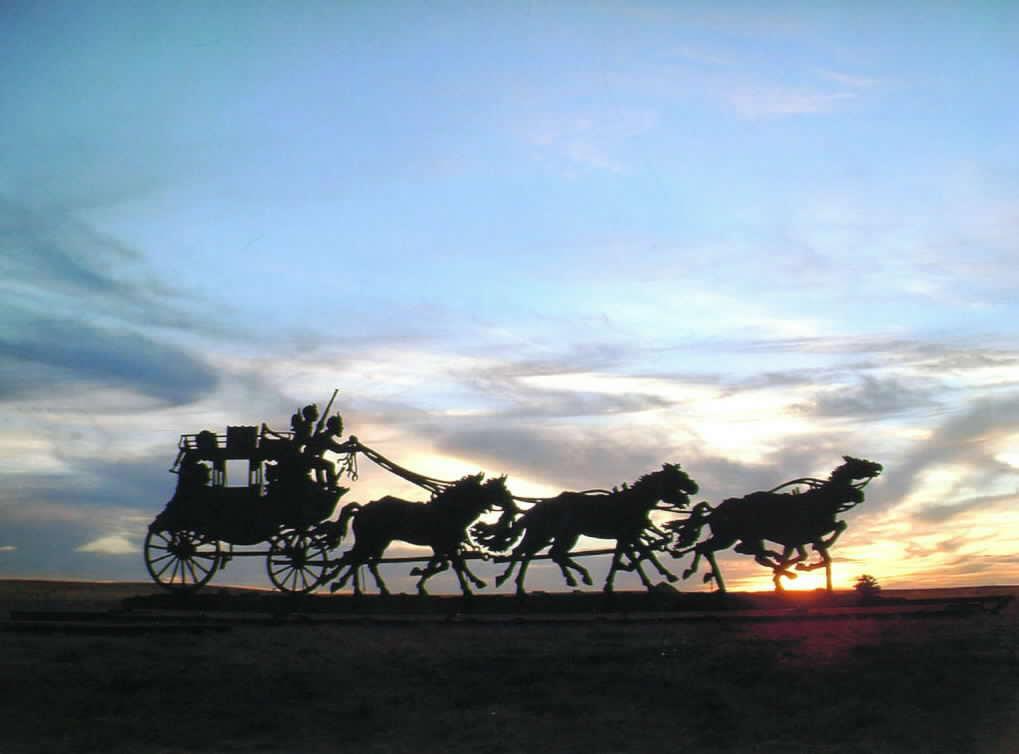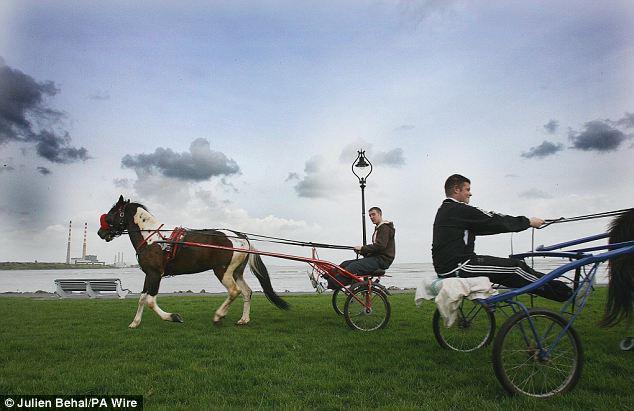The first image is the image on the left, the second image is the image on the right. For the images shown, is this caption "There are three or more horses in at least one image." true? Answer yes or no. Yes. 